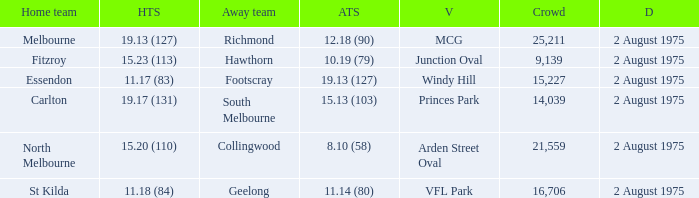Parse the full table. {'header': ['Home team', 'HTS', 'Away team', 'ATS', 'V', 'Crowd', 'D'], 'rows': [['Melbourne', '19.13 (127)', 'Richmond', '12.18 (90)', 'MCG', '25,211', '2 August 1975'], ['Fitzroy', '15.23 (113)', 'Hawthorn', '10.19 (79)', 'Junction Oval', '9,139', '2 August 1975'], ['Essendon', '11.17 (83)', 'Footscray', '19.13 (127)', 'Windy Hill', '15,227', '2 August 1975'], ['Carlton', '19.17 (131)', 'South Melbourne', '15.13 (103)', 'Princes Park', '14,039', '2 August 1975'], ['North Melbourne', '15.20 (110)', 'Collingwood', '8.10 (58)', 'Arden Street Oval', '21,559', '2 August 1975'], ['St Kilda', '11.18 (84)', 'Geelong', '11.14 (80)', 'VFL Park', '16,706', '2 August 1975']]} When did the game at Arden Street Oval occur? 2 August 1975. 